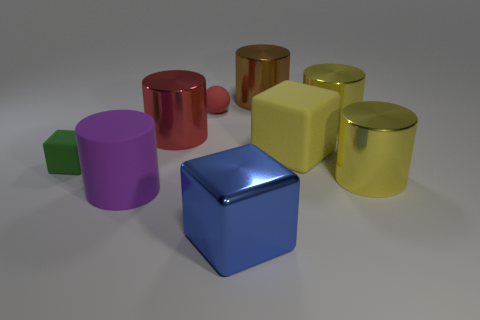There is a large metal thing that is the same color as the rubber sphere; what shape is it?
Ensure brevity in your answer.  Cylinder. Is there a cyan cylinder?
Your response must be concise. No. Is the size of the blue block the same as the yellow shiny thing in front of the yellow rubber object?
Make the answer very short. Yes. Is there a shiny object on the right side of the metallic object in front of the big purple rubber cylinder?
Keep it short and to the point. Yes. There is a cube that is behind the purple matte thing and to the right of the purple rubber cylinder; what is its material?
Give a very brief answer. Rubber. What color is the big shiny cylinder in front of the tiny object on the left side of the large matte object that is left of the big shiny cube?
Give a very brief answer. Yellow. There is a rubber cube that is the same size as the purple cylinder; what is its color?
Your answer should be very brief. Yellow. Does the tiny ball have the same color as the metal cylinder on the left side of the tiny matte ball?
Provide a succinct answer. Yes. What is the material of the yellow object in front of the block that is behind the green matte cube?
Provide a short and direct response. Metal. How many objects are behind the red cylinder and left of the yellow rubber object?
Your response must be concise. 2. 